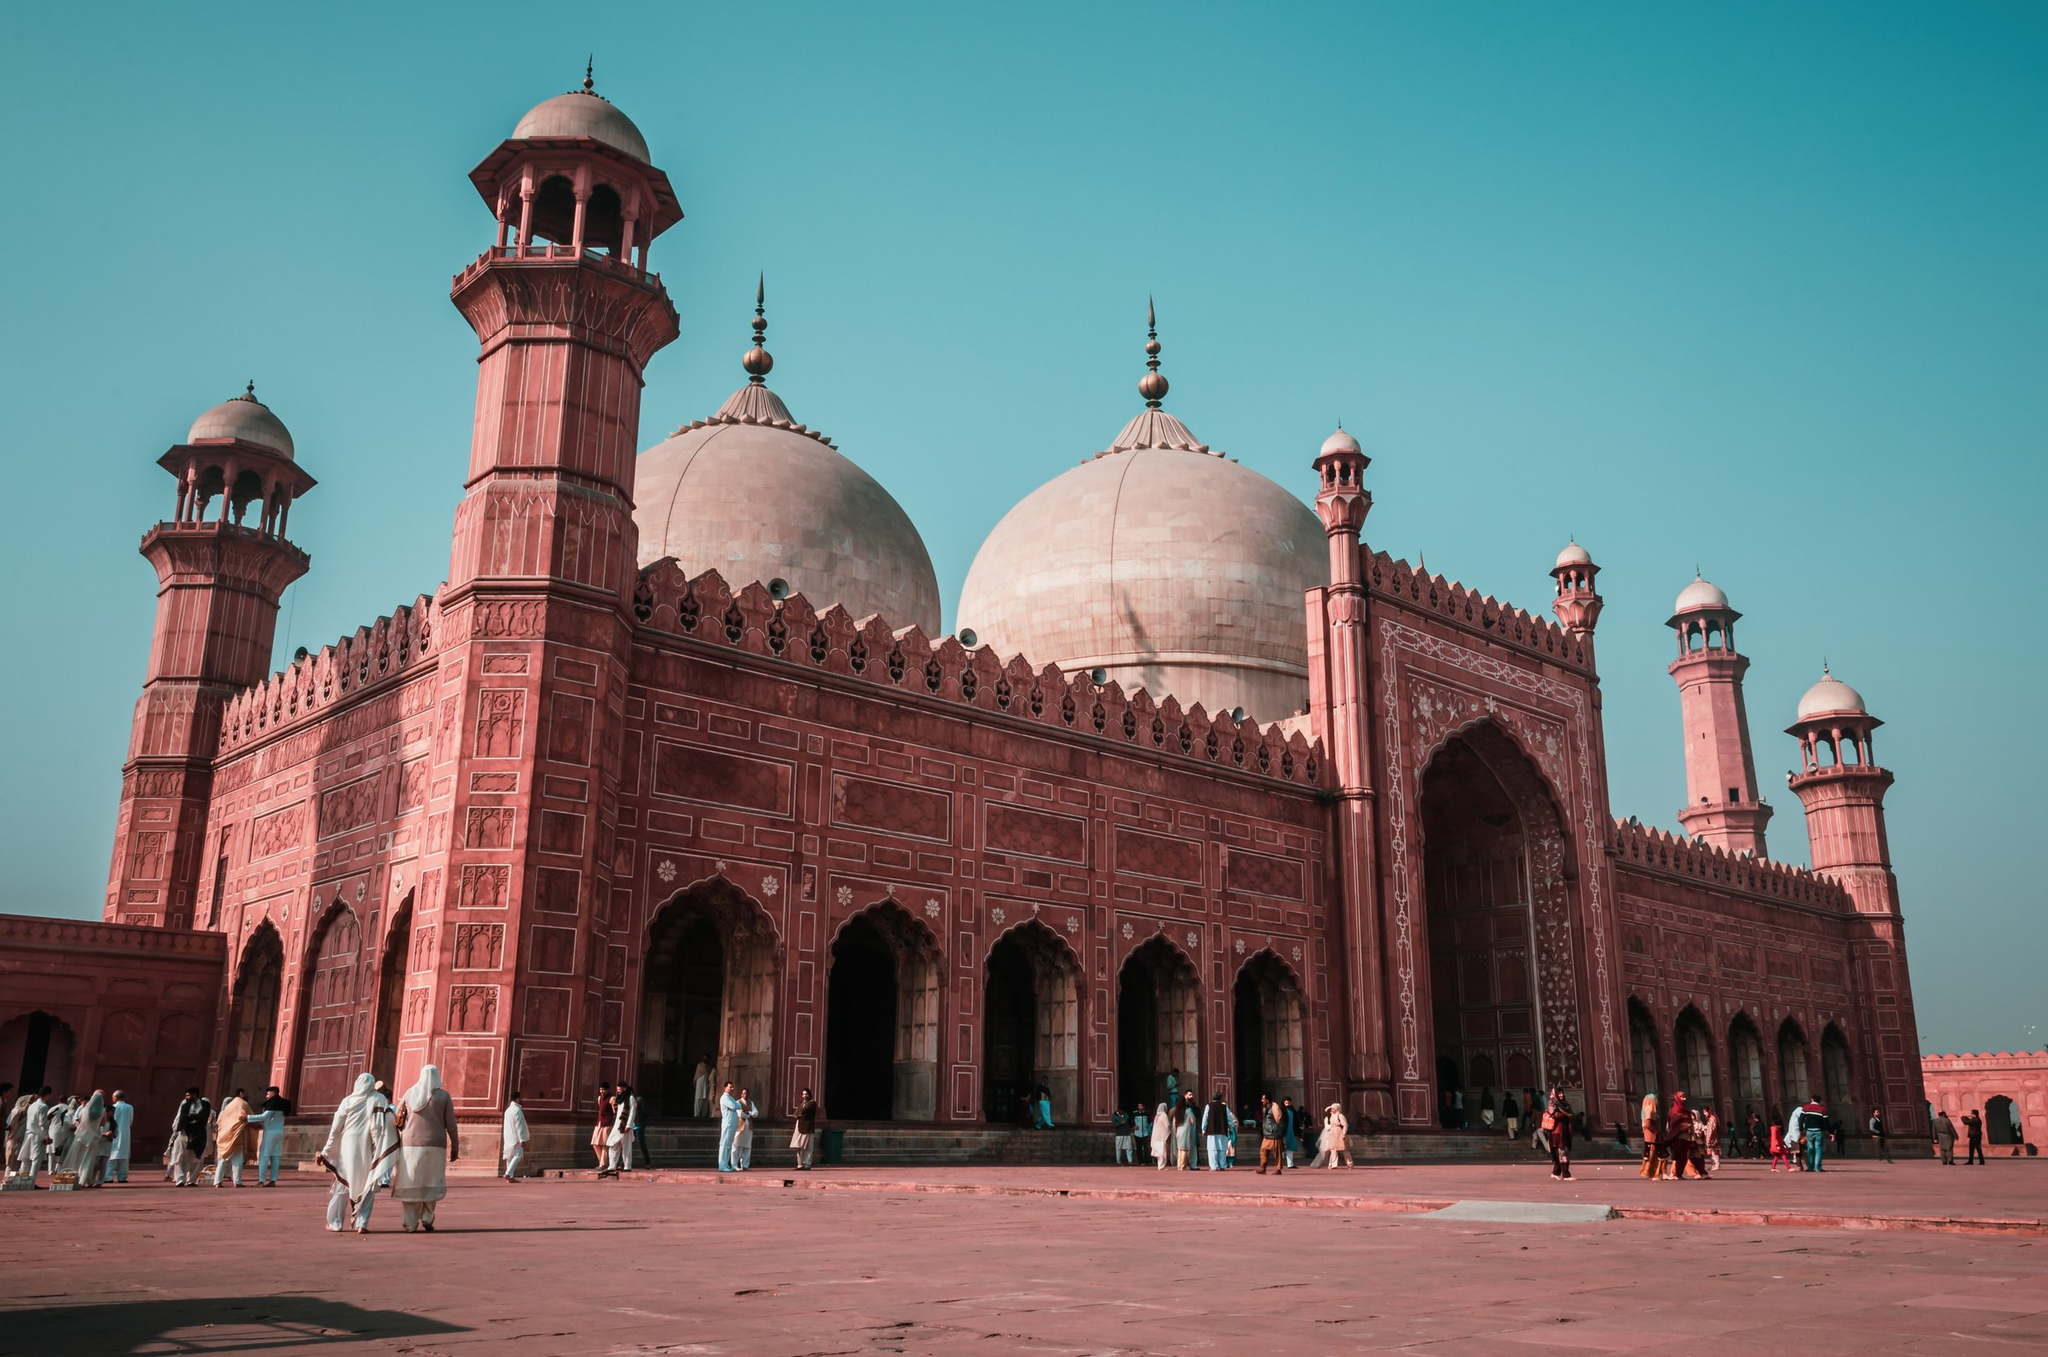What do you think is going on in this snapshot? The image captures the grandeur of the Badshahi Mosque in Lahore, Pakistan. The mosque, a magnificent structure made of red sandstone, stands tall against the backdrop of a clear blue sky. Its white marble domes and minarets add a striking contrast to the red sandstone, enhancing its architectural beauty. The perspective of the photo, taken from a low angle, accentuates the mosque's towering presence. In the foreground, the courtyard bustles with people, adding a touch of life to the otherwise static scene. The mosque, with its intricate design and imposing stature, is a testament to the rich history and culture of Lahore. 